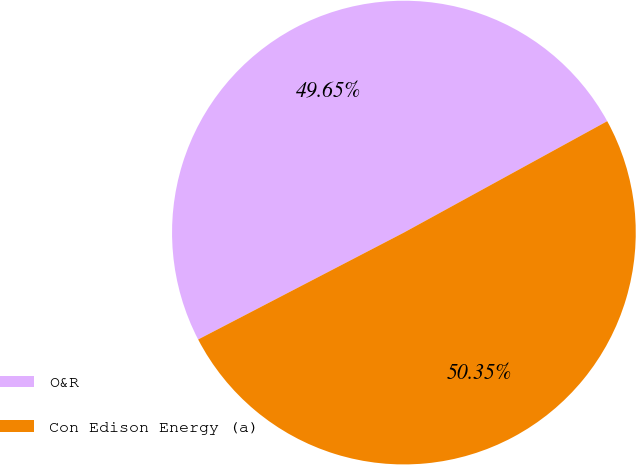<chart> <loc_0><loc_0><loc_500><loc_500><pie_chart><fcel>O&R<fcel>Con Edison Energy (a)<nl><fcel>49.65%<fcel>50.35%<nl></chart> 